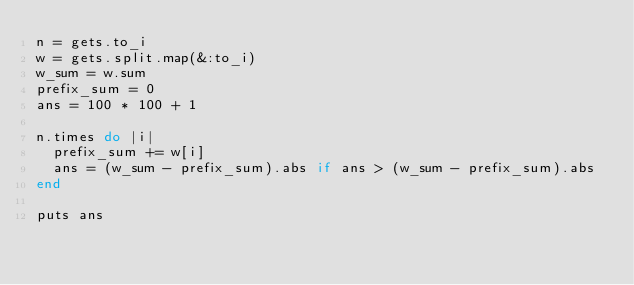<code> <loc_0><loc_0><loc_500><loc_500><_Ruby_>n = gets.to_i
w = gets.split.map(&:to_i)
w_sum = w.sum
prefix_sum = 0
ans = 100 * 100 + 1

n.times do |i|
  prefix_sum += w[i]
  ans = (w_sum - prefix_sum).abs if ans > (w_sum - prefix_sum).abs 
end

puts ans</code> 